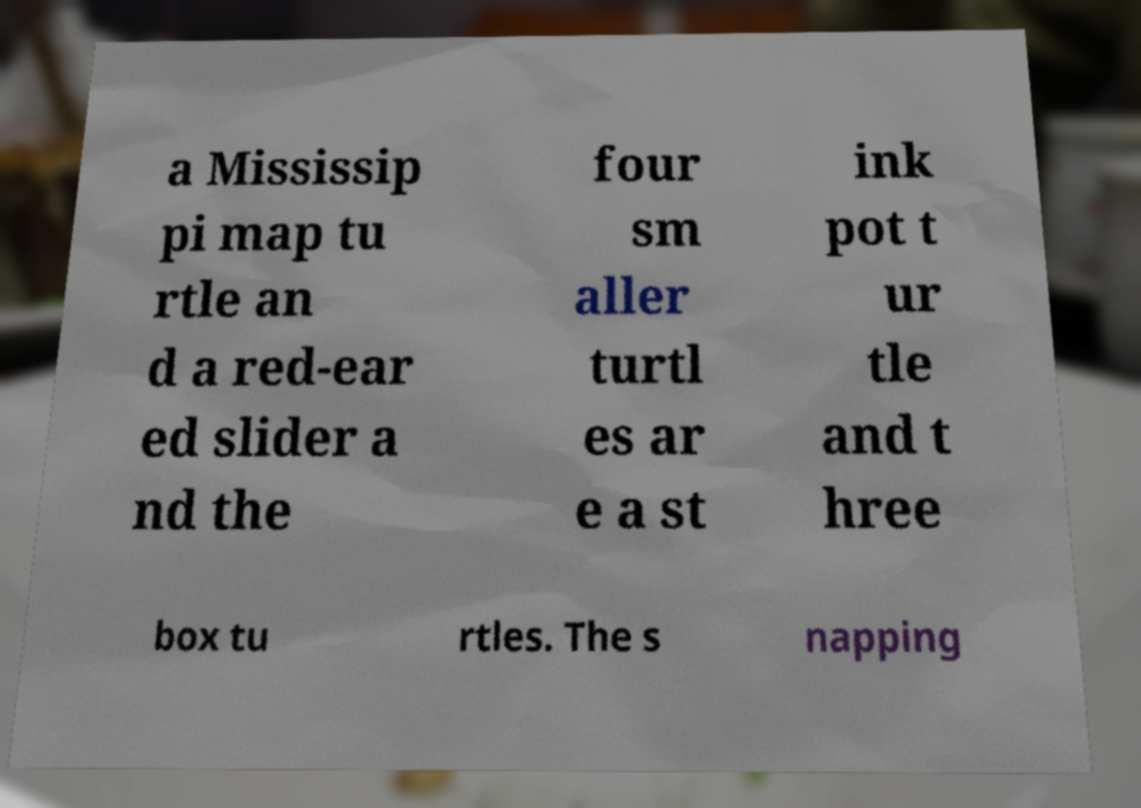Could you extract and type out the text from this image? a Mississip pi map tu rtle an d a red-ear ed slider a nd the four sm aller turtl es ar e a st ink pot t ur tle and t hree box tu rtles. The s napping 